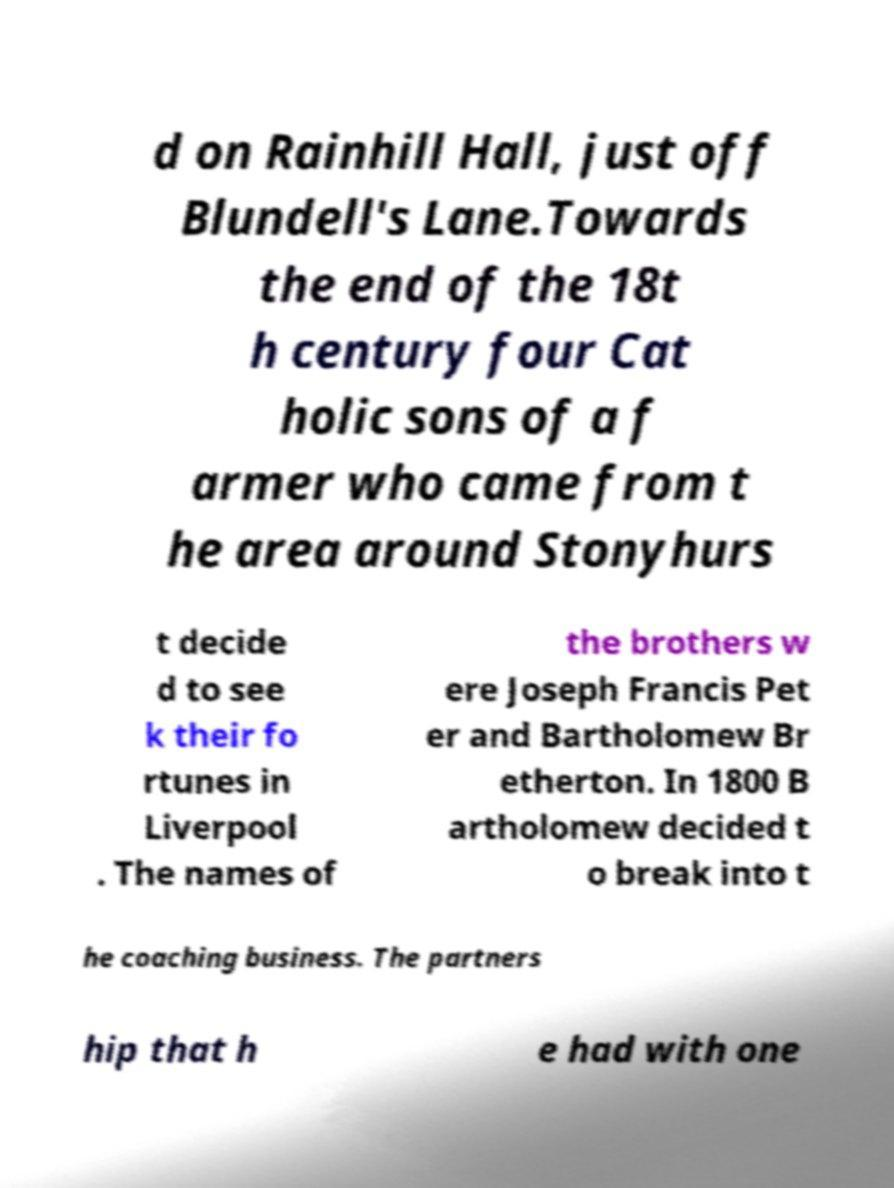For documentation purposes, I need the text within this image transcribed. Could you provide that? d on Rainhill Hall, just off Blundell's Lane.Towards the end of the 18t h century four Cat holic sons of a f armer who came from t he area around Stonyhurs t decide d to see k their fo rtunes in Liverpool . The names of the brothers w ere Joseph Francis Pet er and Bartholomew Br etherton. In 1800 B artholomew decided t o break into t he coaching business. The partners hip that h e had with one 